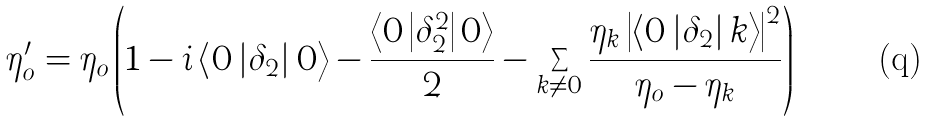<formula> <loc_0><loc_0><loc_500><loc_500>\eta _ { o } ^ { \prime } = \eta _ { o } \left ( 1 - i \left \langle 0 \left | \delta _ { 2 } \right | 0 \right \rangle - \frac { \left \langle 0 \left | \delta _ { 2 } ^ { 2 } \right | 0 \right \rangle } { 2 } - \sum _ { k \neq 0 } \frac { \eta _ { k } \left | \left \langle 0 \left | \delta _ { 2 } \right | k \right \rangle \right | ^ { 2 } } { \eta _ { o } - \eta _ { k } } \right )</formula> 